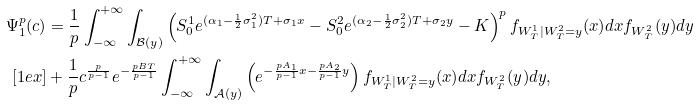<formula> <loc_0><loc_0><loc_500><loc_500>\Psi _ { 1 } ^ { p } ( c ) & = \frac { 1 } { p } \int _ { - \infty } ^ { + \infty } \int _ { \mathcal { B } ( y ) } \left ( S ^ { 1 } _ { 0 } e ^ { ( \alpha _ { 1 } - \frac { 1 } { 2 } \sigma _ { 1 } ^ { 2 } ) T + \sigma _ { 1 } x } - S ^ { 2 } _ { 0 } e ^ { ( \alpha _ { 2 } - \frac { 1 } { 2 } \sigma ^ { 2 } _ { 2 } ) T + \sigma _ { 2 } y } - K \right ) ^ { p } f _ { W ^ { 1 } _ { T } | W ^ { 2 } _ { T } = y } ( x ) d x f _ { W ^ { 2 } _ { T } } ( y ) d y \\ [ 1 e x ] & + \frac { 1 } { p } c ^ { \frac { p } { p - 1 } } e ^ { - \frac { p B T } { p - 1 } } \int _ { - \infty } ^ { + \infty } \int _ { \mathcal { A } ( y ) } \left ( e ^ { - \frac { p A _ { 1 } } { p - 1 } x - \frac { p A _ { 2 } } { p - 1 } y } \right ) f _ { W ^ { 1 } _ { T } | W ^ { 2 } _ { T } = y } ( x ) d x f _ { W ^ { 2 } _ { T } } ( y ) d y ,</formula> 